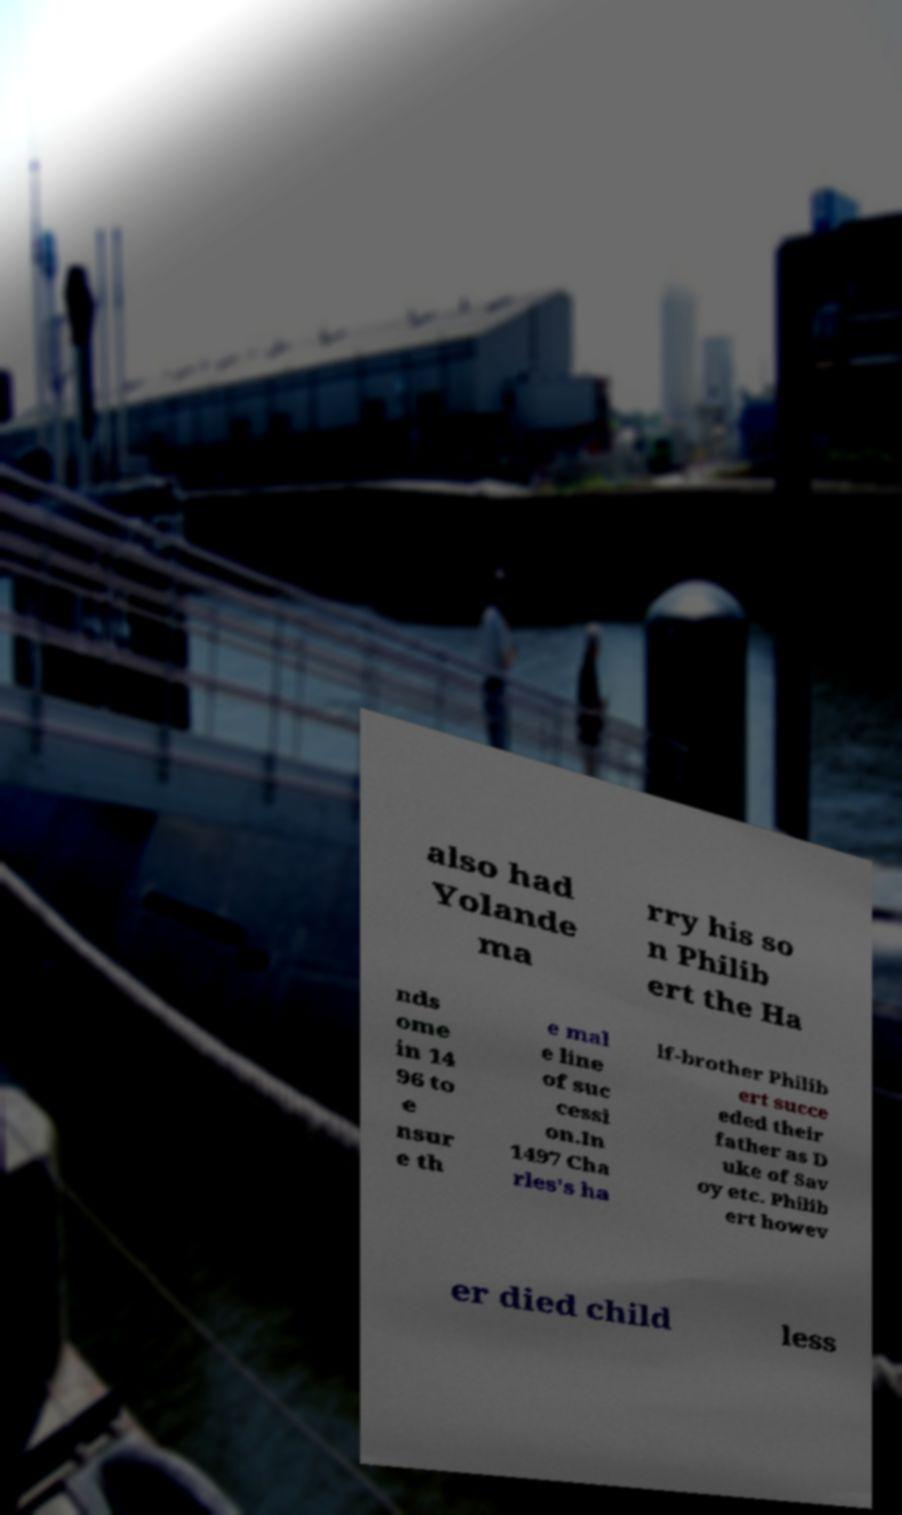Can you accurately transcribe the text from the provided image for me? also had Yolande ma rry his so n Philib ert the Ha nds ome in 14 96 to e nsur e th e mal e line of suc cessi on.In 1497 Cha rles's ha lf-brother Philib ert succe eded their father as D uke of Sav oy etc. Philib ert howev er died child less 